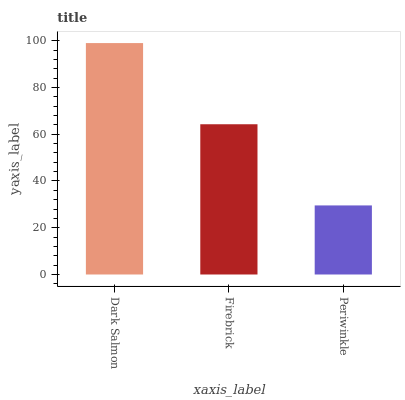Is Periwinkle the minimum?
Answer yes or no. Yes. Is Dark Salmon the maximum?
Answer yes or no. Yes. Is Firebrick the minimum?
Answer yes or no. No. Is Firebrick the maximum?
Answer yes or no. No. Is Dark Salmon greater than Firebrick?
Answer yes or no. Yes. Is Firebrick less than Dark Salmon?
Answer yes or no. Yes. Is Firebrick greater than Dark Salmon?
Answer yes or no. No. Is Dark Salmon less than Firebrick?
Answer yes or no. No. Is Firebrick the high median?
Answer yes or no. Yes. Is Firebrick the low median?
Answer yes or no. Yes. Is Dark Salmon the high median?
Answer yes or no. No. Is Periwinkle the low median?
Answer yes or no. No. 